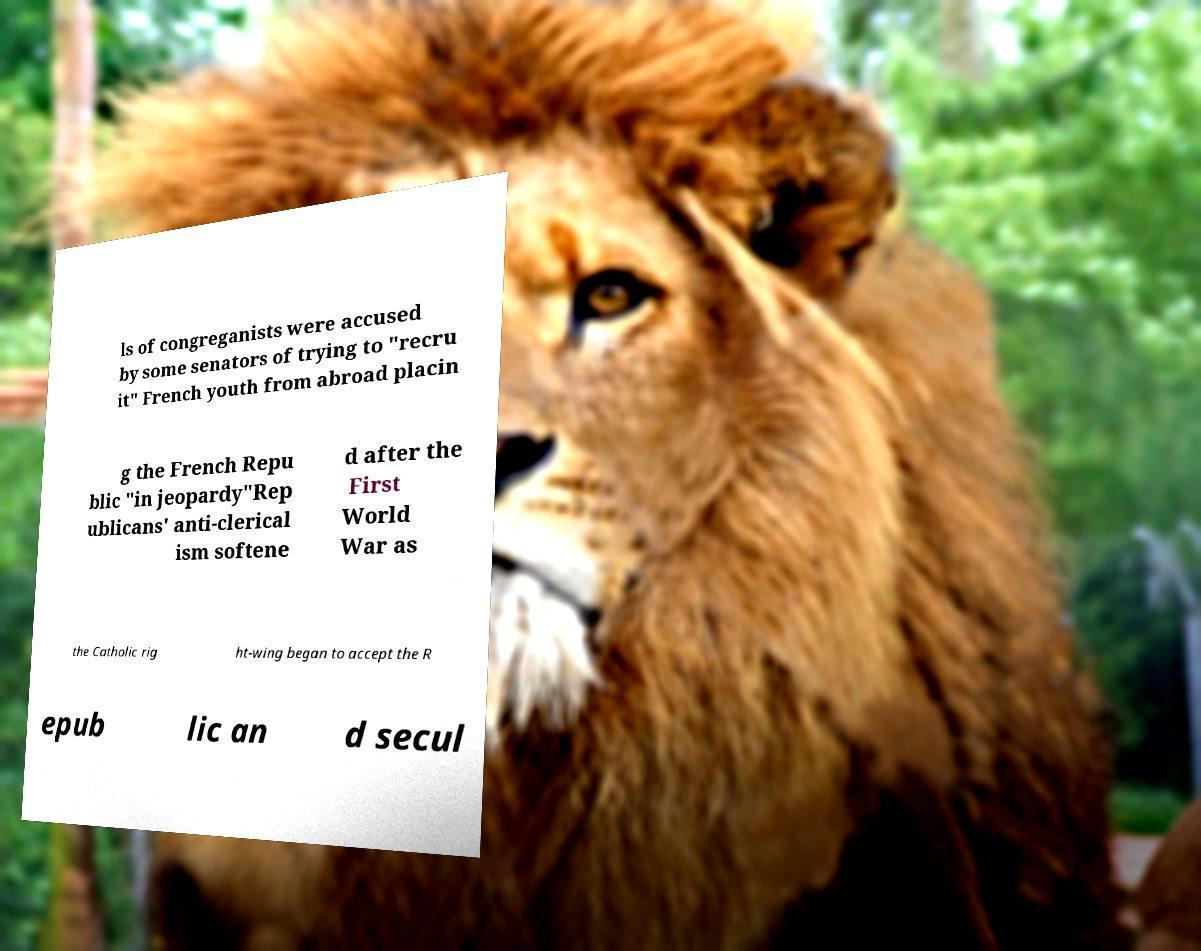Can you read and provide the text displayed in the image?This photo seems to have some interesting text. Can you extract and type it out for me? ls of congreganists were accused by some senators of trying to "recru it" French youth from abroad placin g the French Repu blic "in jeopardy"Rep ublicans' anti-clerical ism softene d after the First World War as the Catholic rig ht-wing began to accept the R epub lic an d secul 